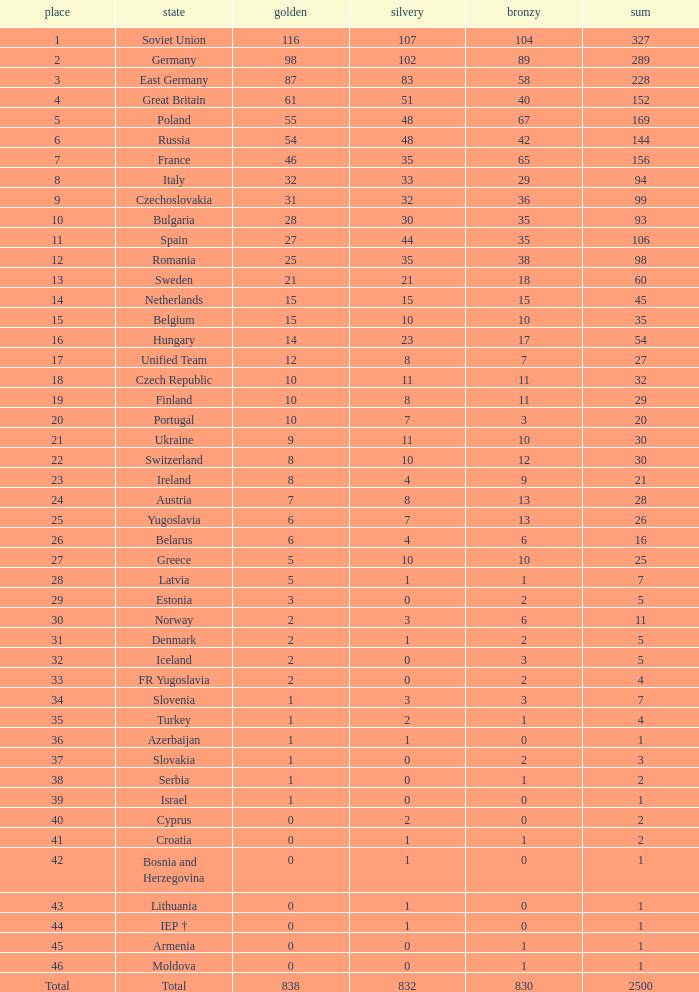What is the rank of the nation with more than 0 silver medals and 38 bronze medals? 12.0. 